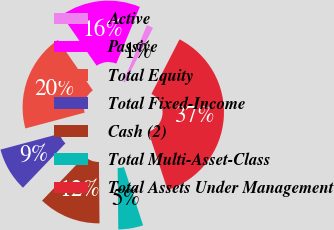Convert chart to OTSL. <chart><loc_0><loc_0><loc_500><loc_500><pie_chart><fcel>Active<fcel>Passive<fcel>Total Equity<fcel>Total Fixed-Income<fcel>Cash (2)<fcel>Total Multi-Asset-Class<fcel>Total Assets Under Management<nl><fcel>1.3%<fcel>15.91%<fcel>19.52%<fcel>8.7%<fcel>12.3%<fcel>4.91%<fcel>37.37%<nl></chart> 